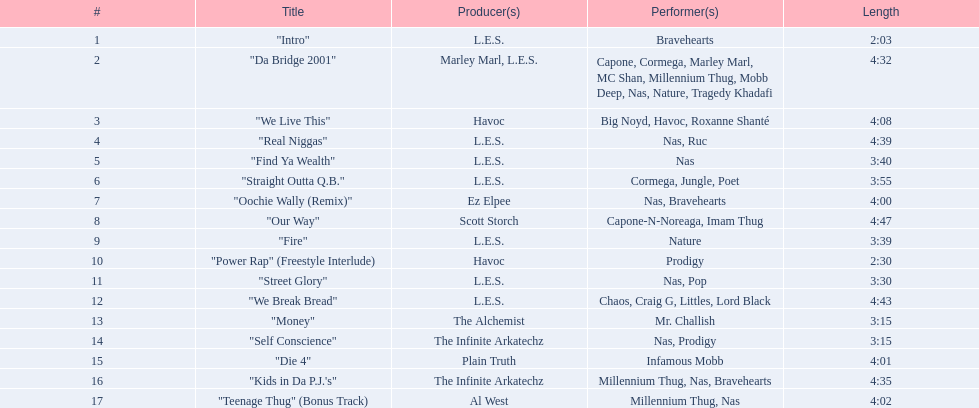What are all the song titles? "Intro", "Da Bridge 2001", "We Live This", "Real Niggas", "Find Ya Wealth", "Straight Outta Q.B.", "Oochie Wally (Remix)", "Our Way", "Fire", "Power Rap" (Freestyle Interlude), "Street Glory", "We Break Bread", "Money", "Self Conscience", "Die 4", "Kids in Da P.J.'s", "Teenage Thug" (Bonus Track). Who produced all these songs? L.E.S., Marley Marl, L.E.S., Ez Elpee, Scott Storch, Havoc, The Alchemist, The Infinite Arkatechz, Plain Truth, Al West. Of the producers, who produced the shortest song? L.E.S. Could you parse the entire table? {'header': ['#', 'Title', 'Producer(s)', 'Performer(s)', 'Length'], 'rows': [['1', '"Intro"', 'L.E.S.', 'Bravehearts', '2:03'], ['2', '"Da Bridge 2001"', 'Marley Marl, L.E.S.', 'Capone, Cormega, Marley Marl, MC Shan, Millennium Thug, Mobb Deep, Nas, Nature, Tragedy Khadafi', '4:32'], ['3', '"We Live This"', 'Havoc', 'Big Noyd, Havoc, Roxanne Shanté', '4:08'], ['4', '"Real Niggas"', 'L.E.S.', 'Nas, Ruc', '4:39'], ['5', '"Find Ya Wealth"', 'L.E.S.', 'Nas', '3:40'], ['6', '"Straight Outta Q.B."', 'L.E.S.', 'Cormega, Jungle, Poet', '3:55'], ['7', '"Oochie Wally (Remix)"', 'Ez Elpee', 'Nas, Bravehearts', '4:00'], ['8', '"Our Way"', 'Scott Storch', 'Capone-N-Noreaga, Imam Thug', '4:47'], ['9', '"Fire"', 'L.E.S.', 'Nature', '3:39'], ['10', '"Power Rap" (Freestyle Interlude)', 'Havoc', 'Prodigy', '2:30'], ['11', '"Street Glory"', 'L.E.S.', 'Nas, Pop', '3:30'], ['12', '"We Break Bread"', 'L.E.S.', 'Chaos, Craig G, Littles, Lord Black', '4:43'], ['13', '"Money"', 'The Alchemist', 'Mr. Challish', '3:15'], ['14', '"Self Conscience"', 'The Infinite Arkatechz', 'Nas, Prodigy', '3:15'], ['15', '"Die 4"', 'Plain Truth', 'Infamous Mobb', '4:01'], ['16', '"Kids in Da P.J.\'s"', 'The Infinite Arkatechz', 'Millennium Thug, Nas, Bravehearts', '4:35'], ['17', '"Teenage Thug" (Bonus Track)', 'Al West', 'Millennium Thug, Nas', '4:02']]} How short was this producer's song? 2:03. 